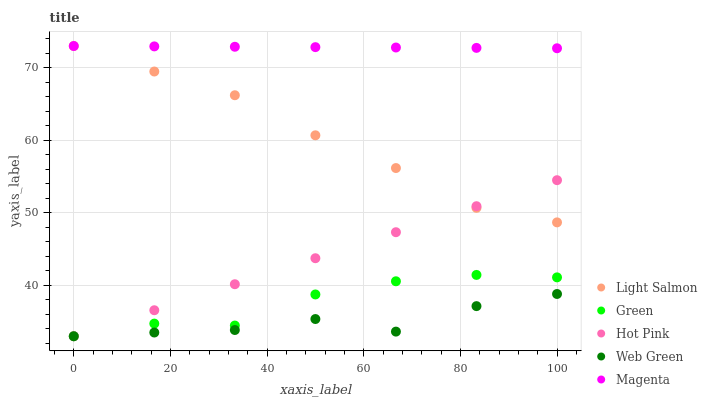Does Web Green have the minimum area under the curve?
Answer yes or no. Yes. Does Magenta have the maximum area under the curve?
Answer yes or no. Yes. Does Hot Pink have the minimum area under the curve?
Answer yes or no. No. Does Hot Pink have the maximum area under the curve?
Answer yes or no. No. Is Magenta the smoothest?
Answer yes or no. Yes. Is Web Green the roughest?
Answer yes or no. Yes. Is Hot Pink the smoothest?
Answer yes or no. No. Is Hot Pink the roughest?
Answer yes or no. No. Does Hot Pink have the lowest value?
Answer yes or no. Yes. Does Magenta have the lowest value?
Answer yes or no. No. Does Magenta have the highest value?
Answer yes or no. Yes. Does Hot Pink have the highest value?
Answer yes or no. No. Is Hot Pink less than Magenta?
Answer yes or no. Yes. Is Magenta greater than Web Green?
Answer yes or no. Yes. Does Web Green intersect Hot Pink?
Answer yes or no. Yes. Is Web Green less than Hot Pink?
Answer yes or no. No. Is Web Green greater than Hot Pink?
Answer yes or no. No. Does Hot Pink intersect Magenta?
Answer yes or no. No. 